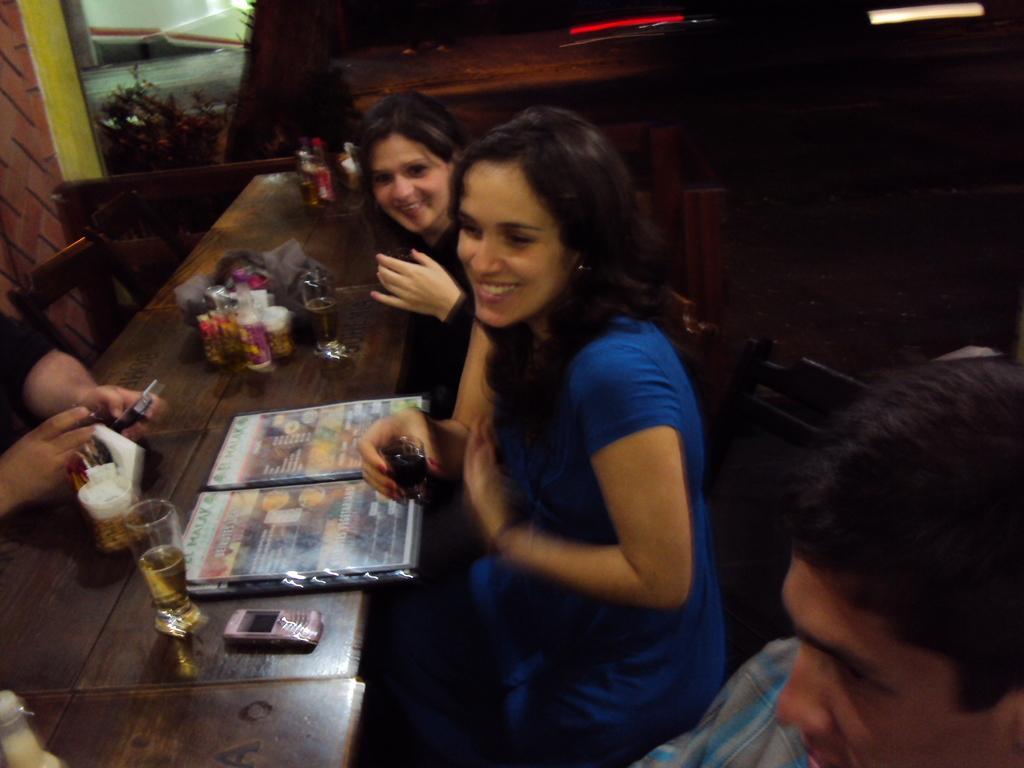Please provide a concise description of this image. there are ladies sitting around a table holding a shot glasses and there are somethings on the table. 